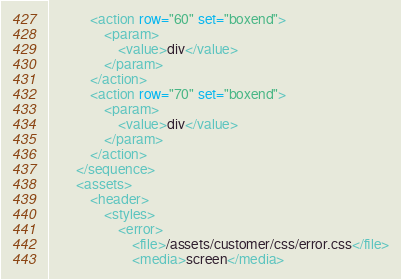<code> <loc_0><loc_0><loc_500><loc_500><_XML_>
			<action row="60" set="boxend">
				<param>
					<value>div</value>
				</param>
			</action>
			<action row="70" set="boxend">
				<param>
					<value>div</value>
				</param>
			</action>
		</sequence>
		<assets>
			<header>
				<styles>
					<error>
						<file>/assets/customer/css/error.css</file>
						<media>screen</media></code> 